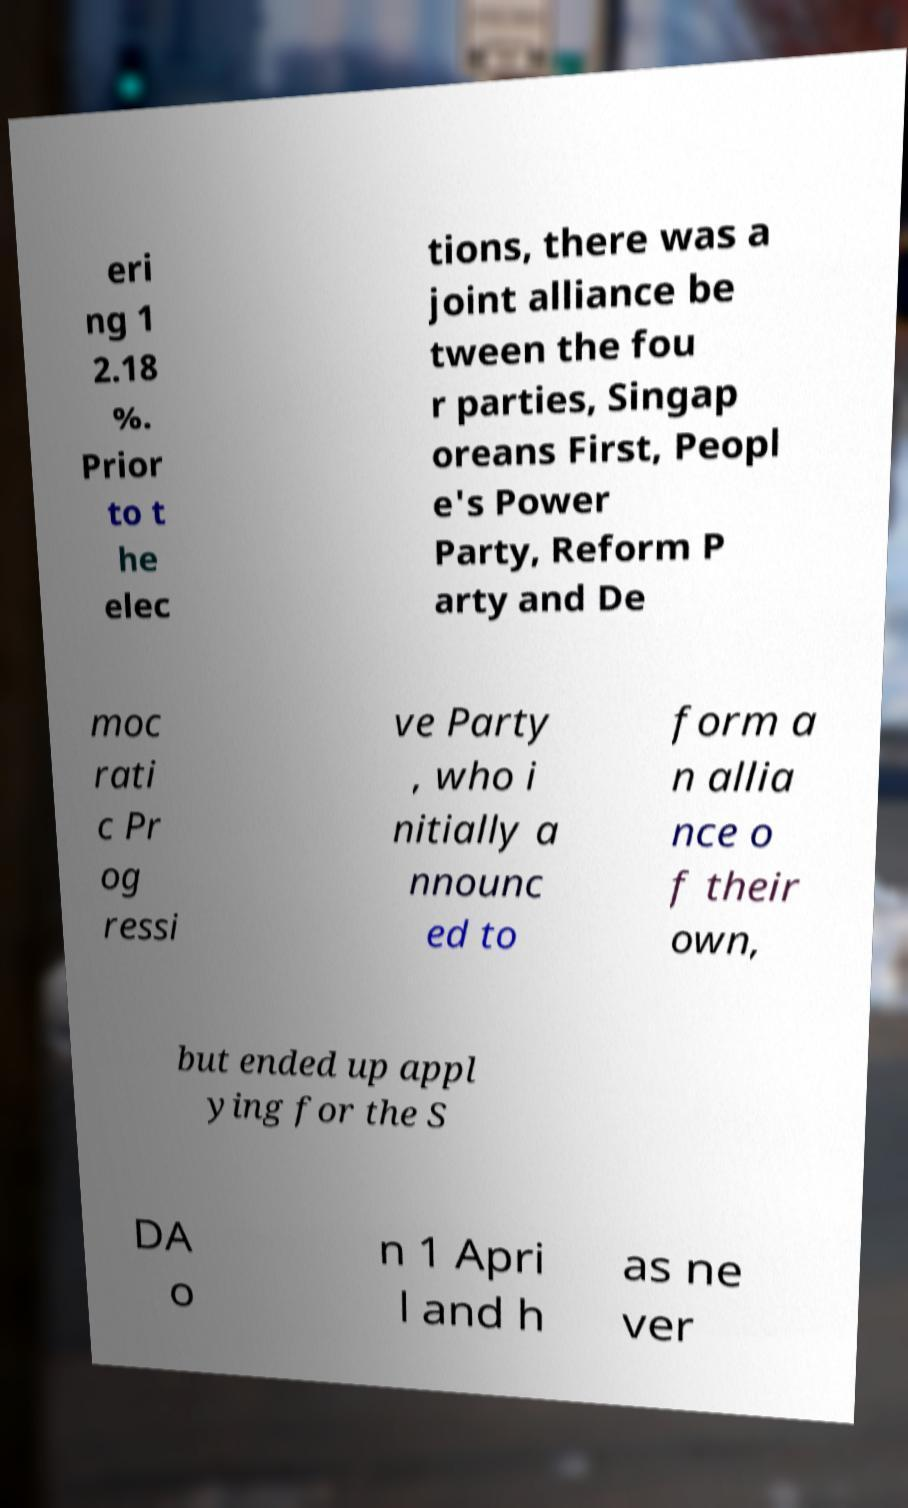What messages or text are displayed in this image? I need them in a readable, typed format. eri ng 1 2.18 %. Prior to t he elec tions, there was a joint alliance be tween the fou r parties, Singap oreans First, Peopl e's Power Party, Reform P arty and De moc rati c Pr og ressi ve Party , who i nitially a nnounc ed to form a n allia nce o f their own, but ended up appl ying for the S DA o n 1 Apri l and h as ne ver 